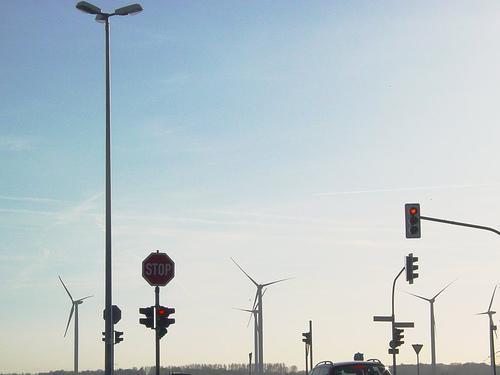How many windmills are in the photo?
Give a very brief answer. 5. How many birds are on the light post on the right?
Give a very brief answer. 0. 